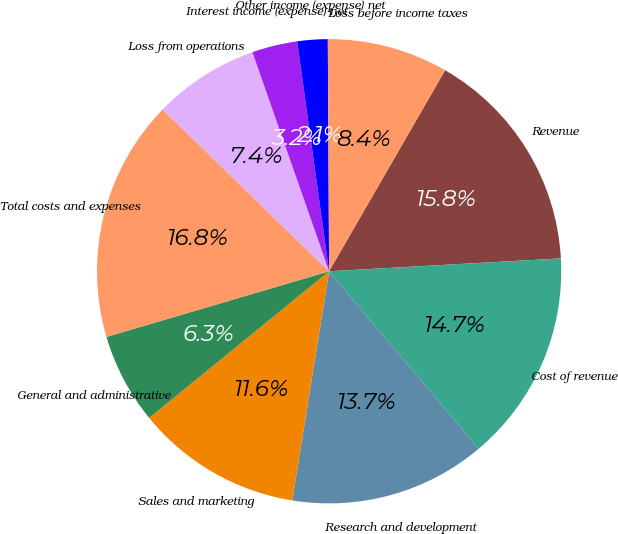Convert chart to OTSL. <chart><loc_0><loc_0><loc_500><loc_500><pie_chart><fcel>Revenue<fcel>Cost of revenue<fcel>Research and development<fcel>Sales and marketing<fcel>General and administrative<fcel>Total costs and expenses<fcel>Loss from operations<fcel>Interest income (expense) net<fcel>Other income (expense) net<fcel>Loss before income taxes<nl><fcel>15.79%<fcel>14.74%<fcel>13.68%<fcel>11.58%<fcel>6.32%<fcel>16.84%<fcel>7.37%<fcel>3.16%<fcel>2.11%<fcel>8.42%<nl></chart> 